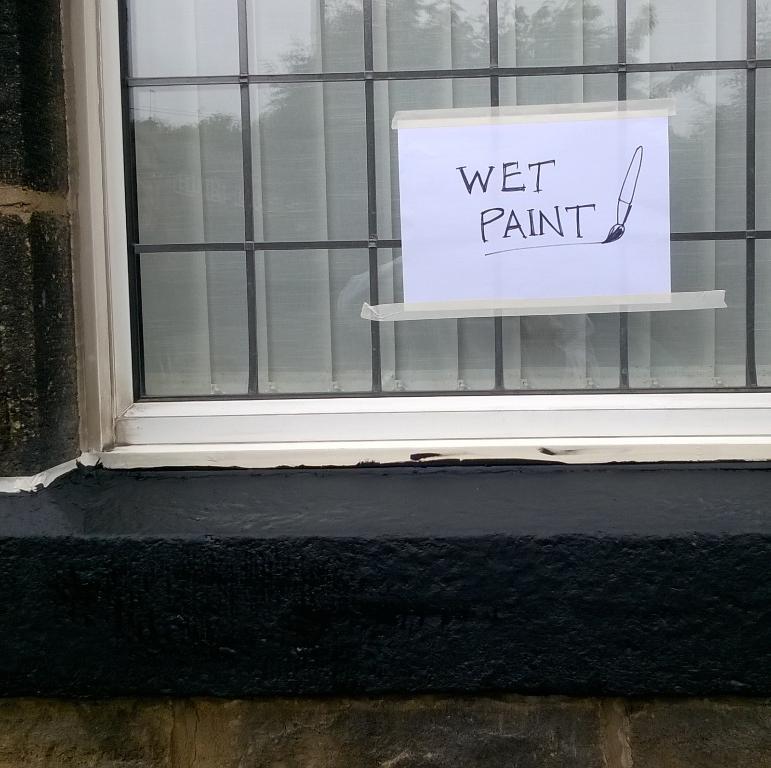Can you describe this image briefly? In this picture we can see a window with a curtain, paper with some text on it and wall. 